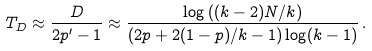<formula> <loc_0><loc_0><loc_500><loc_500>T _ { D } \approx \frac { D } { 2 p ^ { \prime } - 1 } \approx \frac { \log \left ( ( k - 2 ) N / k \right ) } { ( 2 p + 2 ( 1 - p ) / k - 1 ) \log ( k - 1 ) } \, .</formula> 